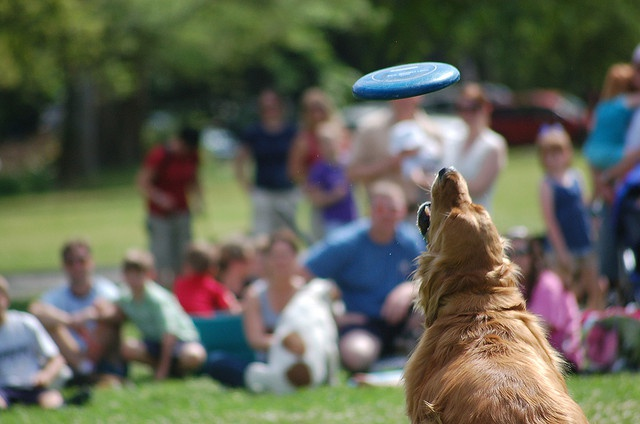Describe the objects in this image and their specific colors. I can see dog in darkgreen, maroon, gray, and tan tones, people in darkgreen, gray, violet, teal, and black tones, people in darkgreen, darkblue, navy, and gray tones, people in darkgreen, gray, black, and darkgray tones, and people in darkgreen, gray, black, darkgray, and lightgray tones in this image. 